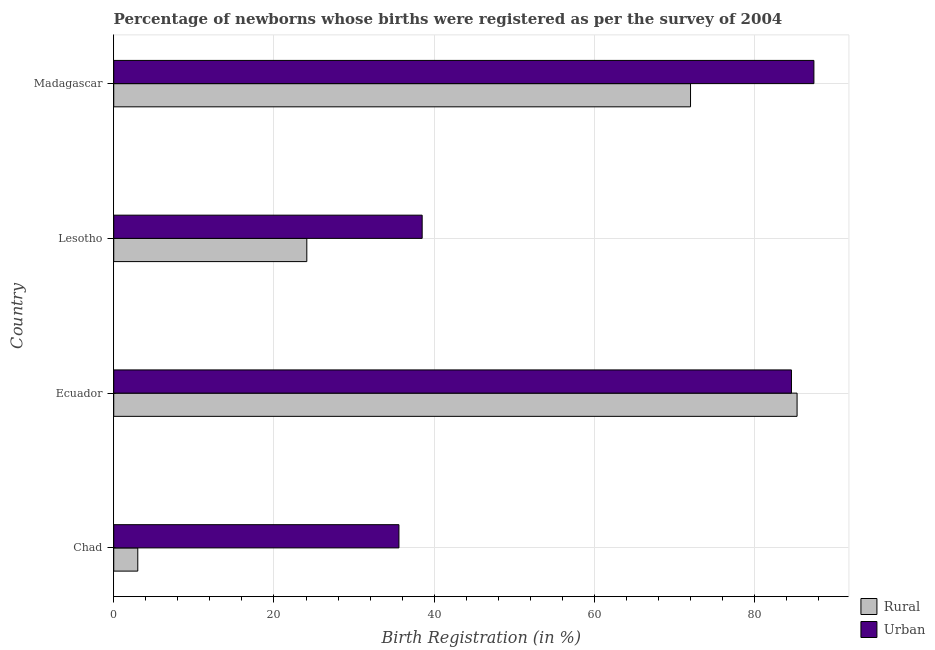How many different coloured bars are there?
Provide a short and direct response. 2. How many groups of bars are there?
Your response must be concise. 4. Are the number of bars per tick equal to the number of legend labels?
Your response must be concise. Yes. What is the label of the 4th group of bars from the top?
Keep it short and to the point. Chad. In how many cases, is the number of bars for a given country not equal to the number of legend labels?
Offer a very short reply. 0. What is the urban birth registration in Madagascar?
Give a very brief answer. 87.4. Across all countries, what is the maximum rural birth registration?
Your response must be concise. 85.3. Across all countries, what is the minimum urban birth registration?
Offer a very short reply. 35.6. In which country was the rural birth registration maximum?
Your answer should be very brief. Ecuador. In which country was the rural birth registration minimum?
Give a very brief answer. Chad. What is the total rural birth registration in the graph?
Provide a succinct answer. 184.4. What is the difference between the rural birth registration in Chad and that in Ecuador?
Offer a very short reply. -82.3. What is the difference between the rural birth registration in Madagascar and the urban birth registration in Lesotho?
Provide a succinct answer. 33.5. What is the average rural birth registration per country?
Provide a short and direct response. 46.1. What is the ratio of the urban birth registration in Chad to that in Lesotho?
Your response must be concise. 0.93. Is the urban birth registration in Chad less than that in Madagascar?
Ensure brevity in your answer.  Yes. Is the difference between the rural birth registration in Ecuador and Lesotho greater than the difference between the urban birth registration in Ecuador and Lesotho?
Your response must be concise. Yes. What is the difference between the highest and the second highest rural birth registration?
Your response must be concise. 13.3. What is the difference between the highest and the lowest urban birth registration?
Make the answer very short. 51.8. What does the 2nd bar from the top in Ecuador represents?
Offer a very short reply. Rural. What does the 1st bar from the bottom in Lesotho represents?
Ensure brevity in your answer.  Rural. Are all the bars in the graph horizontal?
Your answer should be compact. Yes. How many countries are there in the graph?
Offer a terse response. 4. Are the values on the major ticks of X-axis written in scientific E-notation?
Make the answer very short. No. Does the graph contain grids?
Offer a terse response. Yes. Where does the legend appear in the graph?
Make the answer very short. Bottom right. What is the title of the graph?
Provide a short and direct response. Percentage of newborns whose births were registered as per the survey of 2004. What is the label or title of the X-axis?
Your response must be concise. Birth Registration (in %). What is the Birth Registration (in %) in Urban in Chad?
Ensure brevity in your answer.  35.6. What is the Birth Registration (in %) of Rural in Ecuador?
Your response must be concise. 85.3. What is the Birth Registration (in %) of Urban in Ecuador?
Your answer should be very brief. 84.6. What is the Birth Registration (in %) of Rural in Lesotho?
Your answer should be compact. 24.1. What is the Birth Registration (in %) in Urban in Lesotho?
Your answer should be compact. 38.5. What is the Birth Registration (in %) of Rural in Madagascar?
Provide a succinct answer. 72. What is the Birth Registration (in %) in Urban in Madagascar?
Give a very brief answer. 87.4. Across all countries, what is the maximum Birth Registration (in %) of Rural?
Keep it short and to the point. 85.3. Across all countries, what is the maximum Birth Registration (in %) in Urban?
Your answer should be compact. 87.4. Across all countries, what is the minimum Birth Registration (in %) in Rural?
Offer a very short reply. 3. Across all countries, what is the minimum Birth Registration (in %) of Urban?
Ensure brevity in your answer.  35.6. What is the total Birth Registration (in %) of Rural in the graph?
Make the answer very short. 184.4. What is the total Birth Registration (in %) in Urban in the graph?
Provide a short and direct response. 246.1. What is the difference between the Birth Registration (in %) of Rural in Chad and that in Ecuador?
Your answer should be compact. -82.3. What is the difference between the Birth Registration (in %) of Urban in Chad and that in Ecuador?
Keep it short and to the point. -49. What is the difference between the Birth Registration (in %) of Rural in Chad and that in Lesotho?
Your answer should be compact. -21.1. What is the difference between the Birth Registration (in %) of Rural in Chad and that in Madagascar?
Keep it short and to the point. -69. What is the difference between the Birth Registration (in %) in Urban in Chad and that in Madagascar?
Keep it short and to the point. -51.8. What is the difference between the Birth Registration (in %) in Rural in Ecuador and that in Lesotho?
Offer a terse response. 61.2. What is the difference between the Birth Registration (in %) of Urban in Ecuador and that in Lesotho?
Keep it short and to the point. 46.1. What is the difference between the Birth Registration (in %) in Urban in Ecuador and that in Madagascar?
Provide a short and direct response. -2.8. What is the difference between the Birth Registration (in %) in Rural in Lesotho and that in Madagascar?
Make the answer very short. -47.9. What is the difference between the Birth Registration (in %) of Urban in Lesotho and that in Madagascar?
Make the answer very short. -48.9. What is the difference between the Birth Registration (in %) in Rural in Chad and the Birth Registration (in %) in Urban in Ecuador?
Make the answer very short. -81.6. What is the difference between the Birth Registration (in %) of Rural in Chad and the Birth Registration (in %) of Urban in Lesotho?
Ensure brevity in your answer.  -35.5. What is the difference between the Birth Registration (in %) in Rural in Chad and the Birth Registration (in %) in Urban in Madagascar?
Offer a very short reply. -84.4. What is the difference between the Birth Registration (in %) of Rural in Ecuador and the Birth Registration (in %) of Urban in Lesotho?
Offer a terse response. 46.8. What is the difference between the Birth Registration (in %) of Rural in Ecuador and the Birth Registration (in %) of Urban in Madagascar?
Make the answer very short. -2.1. What is the difference between the Birth Registration (in %) of Rural in Lesotho and the Birth Registration (in %) of Urban in Madagascar?
Keep it short and to the point. -63.3. What is the average Birth Registration (in %) in Rural per country?
Make the answer very short. 46.1. What is the average Birth Registration (in %) in Urban per country?
Make the answer very short. 61.52. What is the difference between the Birth Registration (in %) of Rural and Birth Registration (in %) of Urban in Chad?
Your response must be concise. -32.6. What is the difference between the Birth Registration (in %) of Rural and Birth Registration (in %) of Urban in Lesotho?
Keep it short and to the point. -14.4. What is the difference between the Birth Registration (in %) of Rural and Birth Registration (in %) of Urban in Madagascar?
Provide a short and direct response. -15.4. What is the ratio of the Birth Registration (in %) in Rural in Chad to that in Ecuador?
Your answer should be very brief. 0.04. What is the ratio of the Birth Registration (in %) of Urban in Chad to that in Ecuador?
Provide a short and direct response. 0.42. What is the ratio of the Birth Registration (in %) in Rural in Chad to that in Lesotho?
Offer a terse response. 0.12. What is the ratio of the Birth Registration (in %) in Urban in Chad to that in Lesotho?
Your response must be concise. 0.92. What is the ratio of the Birth Registration (in %) in Rural in Chad to that in Madagascar?
Your answer should be compact. 0.04. What is the ratio of the Birth Registration (in %) in Urban in Chad to that in Madagascar?
Make the answer very short. 0.41. What is the ratio of the Birth Registration (in %) of Rural in Ecuador to that in Lesotho?
Your answer should be very brief. 3.54. What is the ratio of the Birth Registration (in %) of Urban in Ecuador to that in Lesotho?
Give a very brief answer. 2.2. What is the ratio of the Birth Registration (in %) of Rural in Ecuador to that in Madagascar?
Provide a succinct answer. 1.18. What is the ratio of the Birth Registration (in %) in Rural in Lesotho to that in Madagascar?
Give a very brief answer. 0.33. What is the ratio of the Birth Registration (in %) of Urban in Lesotho to that in Madagascar?
Provide a short and direct response. 0.44. What is the difference between the highest and the second highest Birth Registration (in %) in Urban?
Ensure brevity in your answer.  2.8. What is the difference between the highest and the lowest Birth Registration (in %) of Rural?
Make the answer very short. 82.3. What is the difference between the highest and the lowest Birth Registration (in %) of Urban?
Provide a succinct answer. 51.8. 